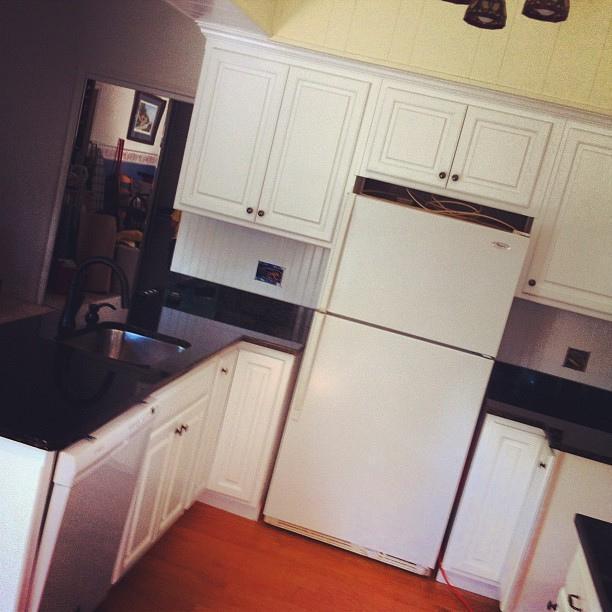How many refrigerators are there?
Give a very brief answer. 1. How many sinks are in the picture?
Give a very brief answer. 1. 